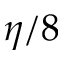<formula> <loc_0><loc_0><loc_500><loc_500>\eta / 8</formula> 